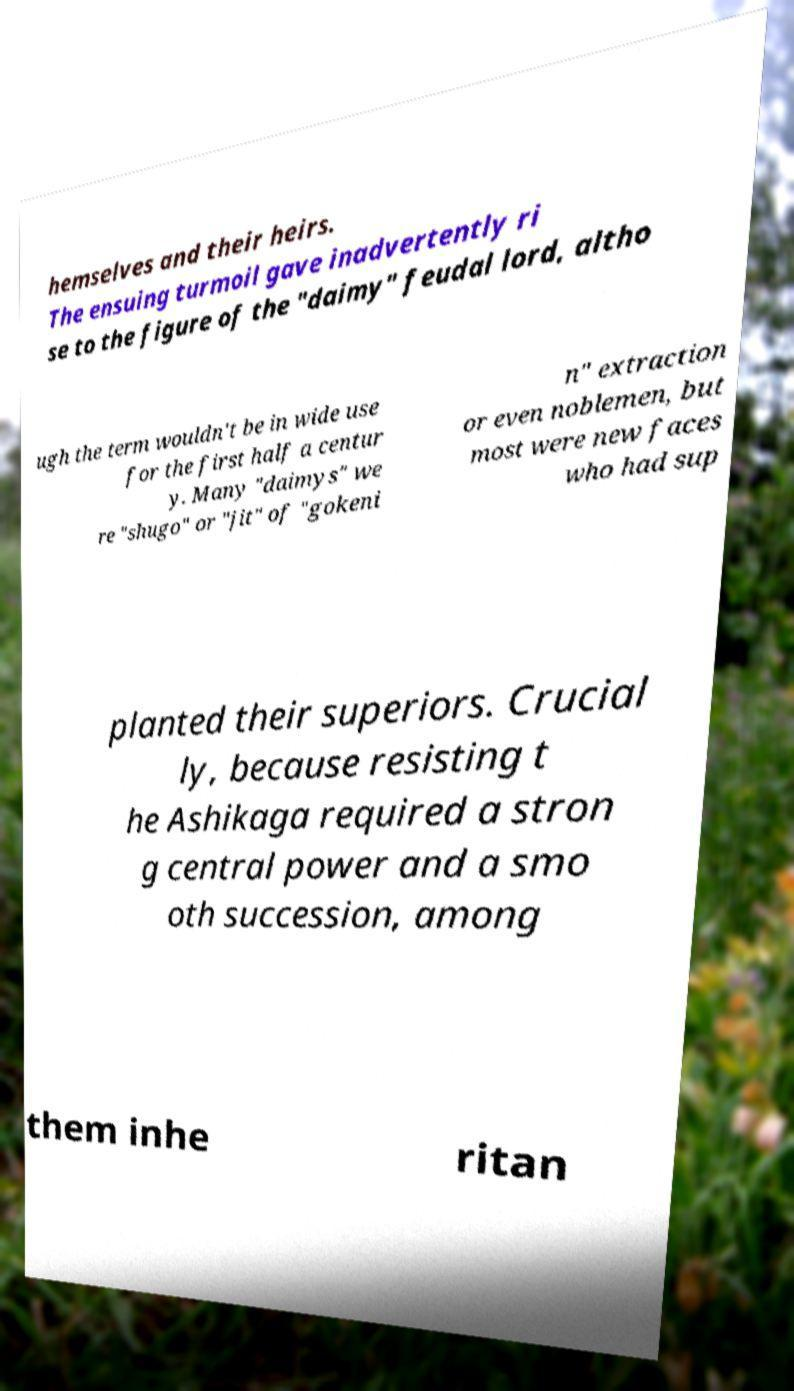Can you accurately transcribe the text from the provided image for me? hemselves and their heirs. The ensuing turmoil gave inadvertently ri se to the figure of the "daimy" feudal lord, altho ugh the term wouldn't be in wide use for the first half a centur y. Many "daimys" we re "shugo" or "jit" of "gokeni n" extraction or even noblemen, but most were new faces who had sup planted their superiors. Crucial ly, because resisting t he Ashikaga required a stron g central power and a smo oth succession, among them inhe ritan 